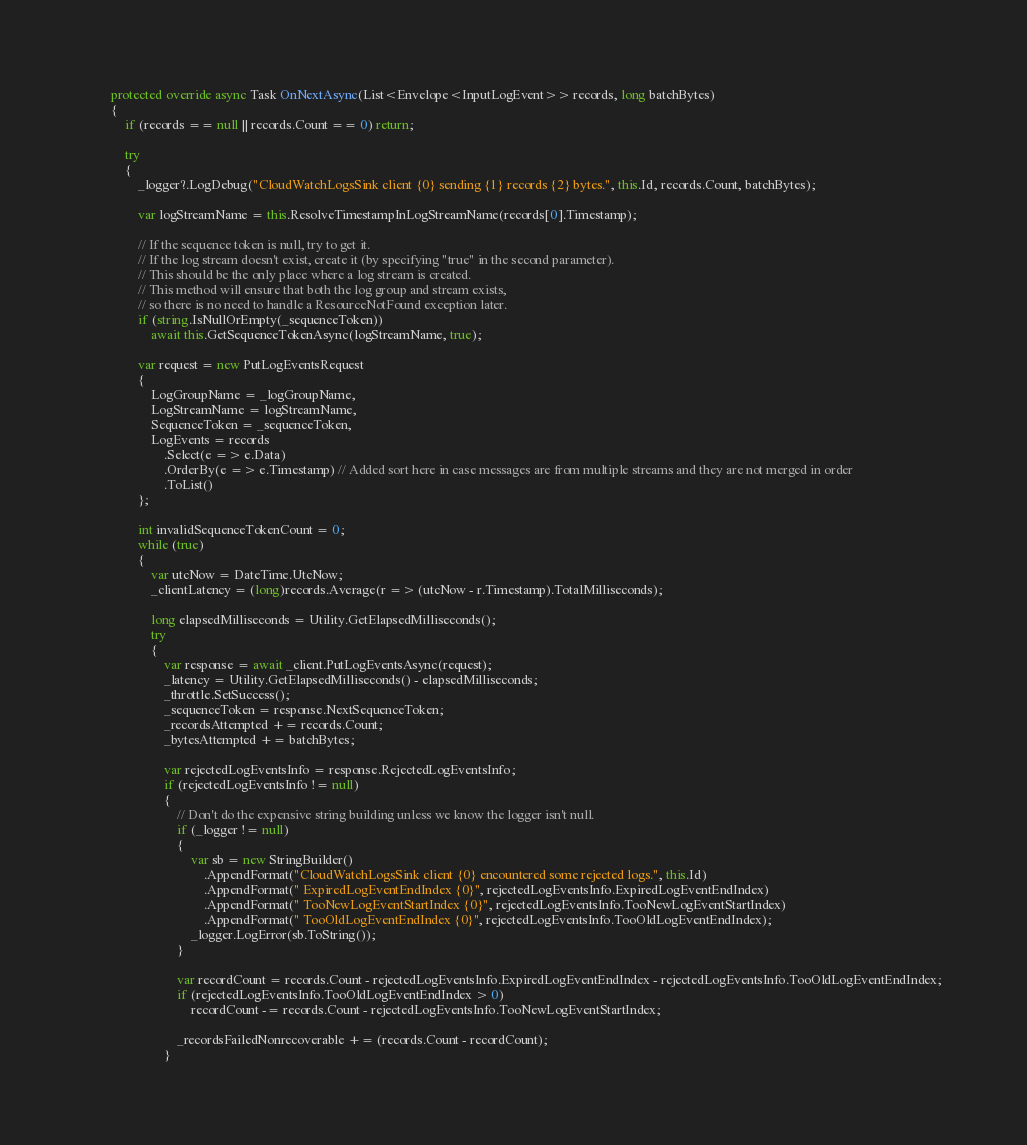<code> <loc_0><loc_0><loc_500><loc_500><_C#_>        protected override async Task OnNextAsync(List<Envelope<InputLogEvent>> records, long batchBytes)
        {
            if (records == null || records.Count == 0) return;

            try
            {
                _logger?.LogDebug("CloudWatchLogsSink client {0} sending {1} records {2} bytes.", this.Id, records.Count, batchBytes);

                var logStreamName = this.ResolveTimestampInLogStreamName(records[0].Timestamp);

                // If the sequence token is null, try to get it.
                // If the log stream doesn't exist, create it (by specifying "true" in the second parameter).
                // This should be the only place where a log stream is created.
                // This method will ensure that both the log group and stream exists,
                // so there is no need to handle a ResourceNotFound exception later.
                if (string.IsNullOrEmpty(_sequenceToken))
                    await this.GetSequenceTokenAsync(logStreamName, true);

                var request = new PutLogEventsRequest
                {
                    LogGroupName = _logGroupName,
                    LogStreamName = logStreamName,
                    SequenceToken = _sequenceToken,
                    LogEvents = records
                        .Select(e => e.Data)
                        .OrderBy(e => e.Timestamp) // Added sort here in case messages are from multiple streams and they are not merged in order
                        .ToList()
                };

                int invalidSequenceTokenCount = 0;
                while (true)
                {
                    var utcNow = DateTime.UtcNow;
                    _clientLatency = (long)records.Average(r => (utcNow - r.Timestamp).TotalMilliseconds);

                    long elapsedMilliseconds = Utility.GetElapsedMilliseconds();
                    try
                    {
                        var response = await _client.PutLogEventsAsync(request);
                        _latency = Utility.GetElapsedMilliseconds() - elapsedMilliseconds;
                        _throttle.SetSuccess();
                        _sequenceToken = response.NextSequenceToken;
                        _recordsAttempted += records.Count;
                        _bytesAttempted += batchBytes;

                        var rejectedLogEventsInfo = response.RejectedLogEventsInfo;
                        if (rejectedLogEventsInfo != null)
                        {
                            // Don't do the expensive string building unless we know the logger isn't null.
                            if (_logger != null)
                            {
                                var sb = new StringBuilder()
                                    .AppendFormat("CloudWatchLogsSink client {0} encountered some rejected logs.", this.Id)
                                    .AppendFormat(" ExpiredLogEventEndIndex {0}", rejectedLogEventsInfo.ExpiredLogEventEndIndex)
                                    .AppendFormat(" TooNewLogEventStartIndex {0}", rejectedLogEventsInfo.TooNewLogEventStartIndex)
                                    .AppendFormat(" TooOldLogEventEndIndex {0}", rejectedLogEventsInfo.TooOldLogEventEndIndex);
                                _logger.LogError(sb.ToString());
                            }
                            
                            var recordCount = records.Count - rejectedLogEventsInfo.ExpiredLogEventEndIndex - rejectedLogEventsInfo.TooOldLogEventEndIndex;
                            if (rejectedLogEventsInfo.TooOldLogEventEndIndex > 0)
                                recordCount -= records.Count - rejectedLogEventsInfo.TooNewLogEventStartIndex;

                            _recordsFailedNonrecoverable += (records.Count - recordCount);
                        }
</code> 